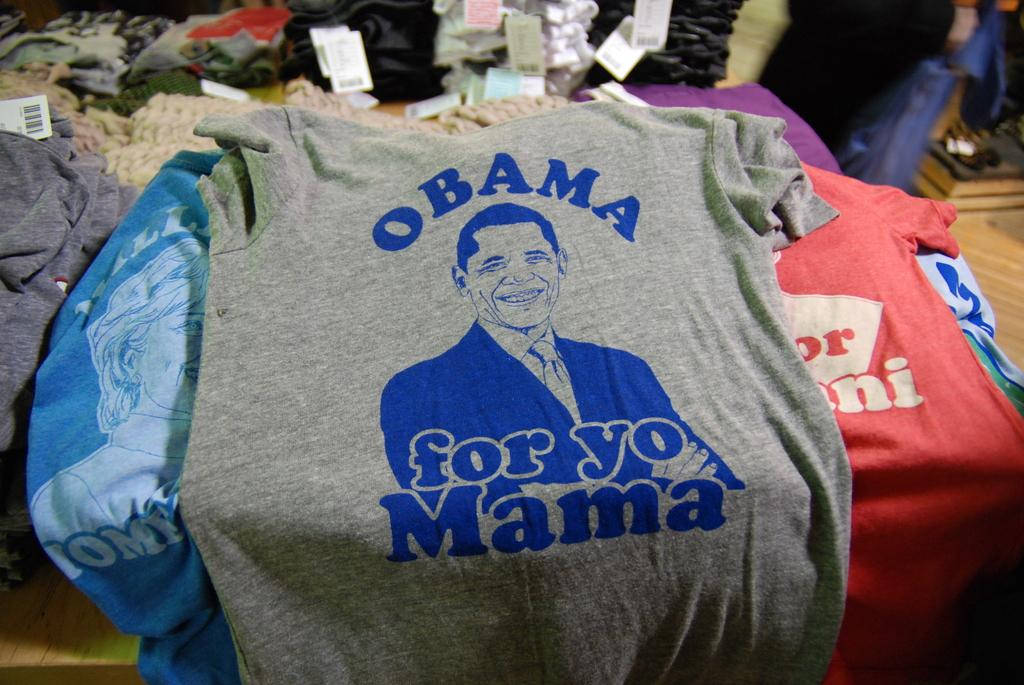<image>
Relay a brief, clear account of the picture shown. A grey t-shirt referencing Obama along with other shirts. 